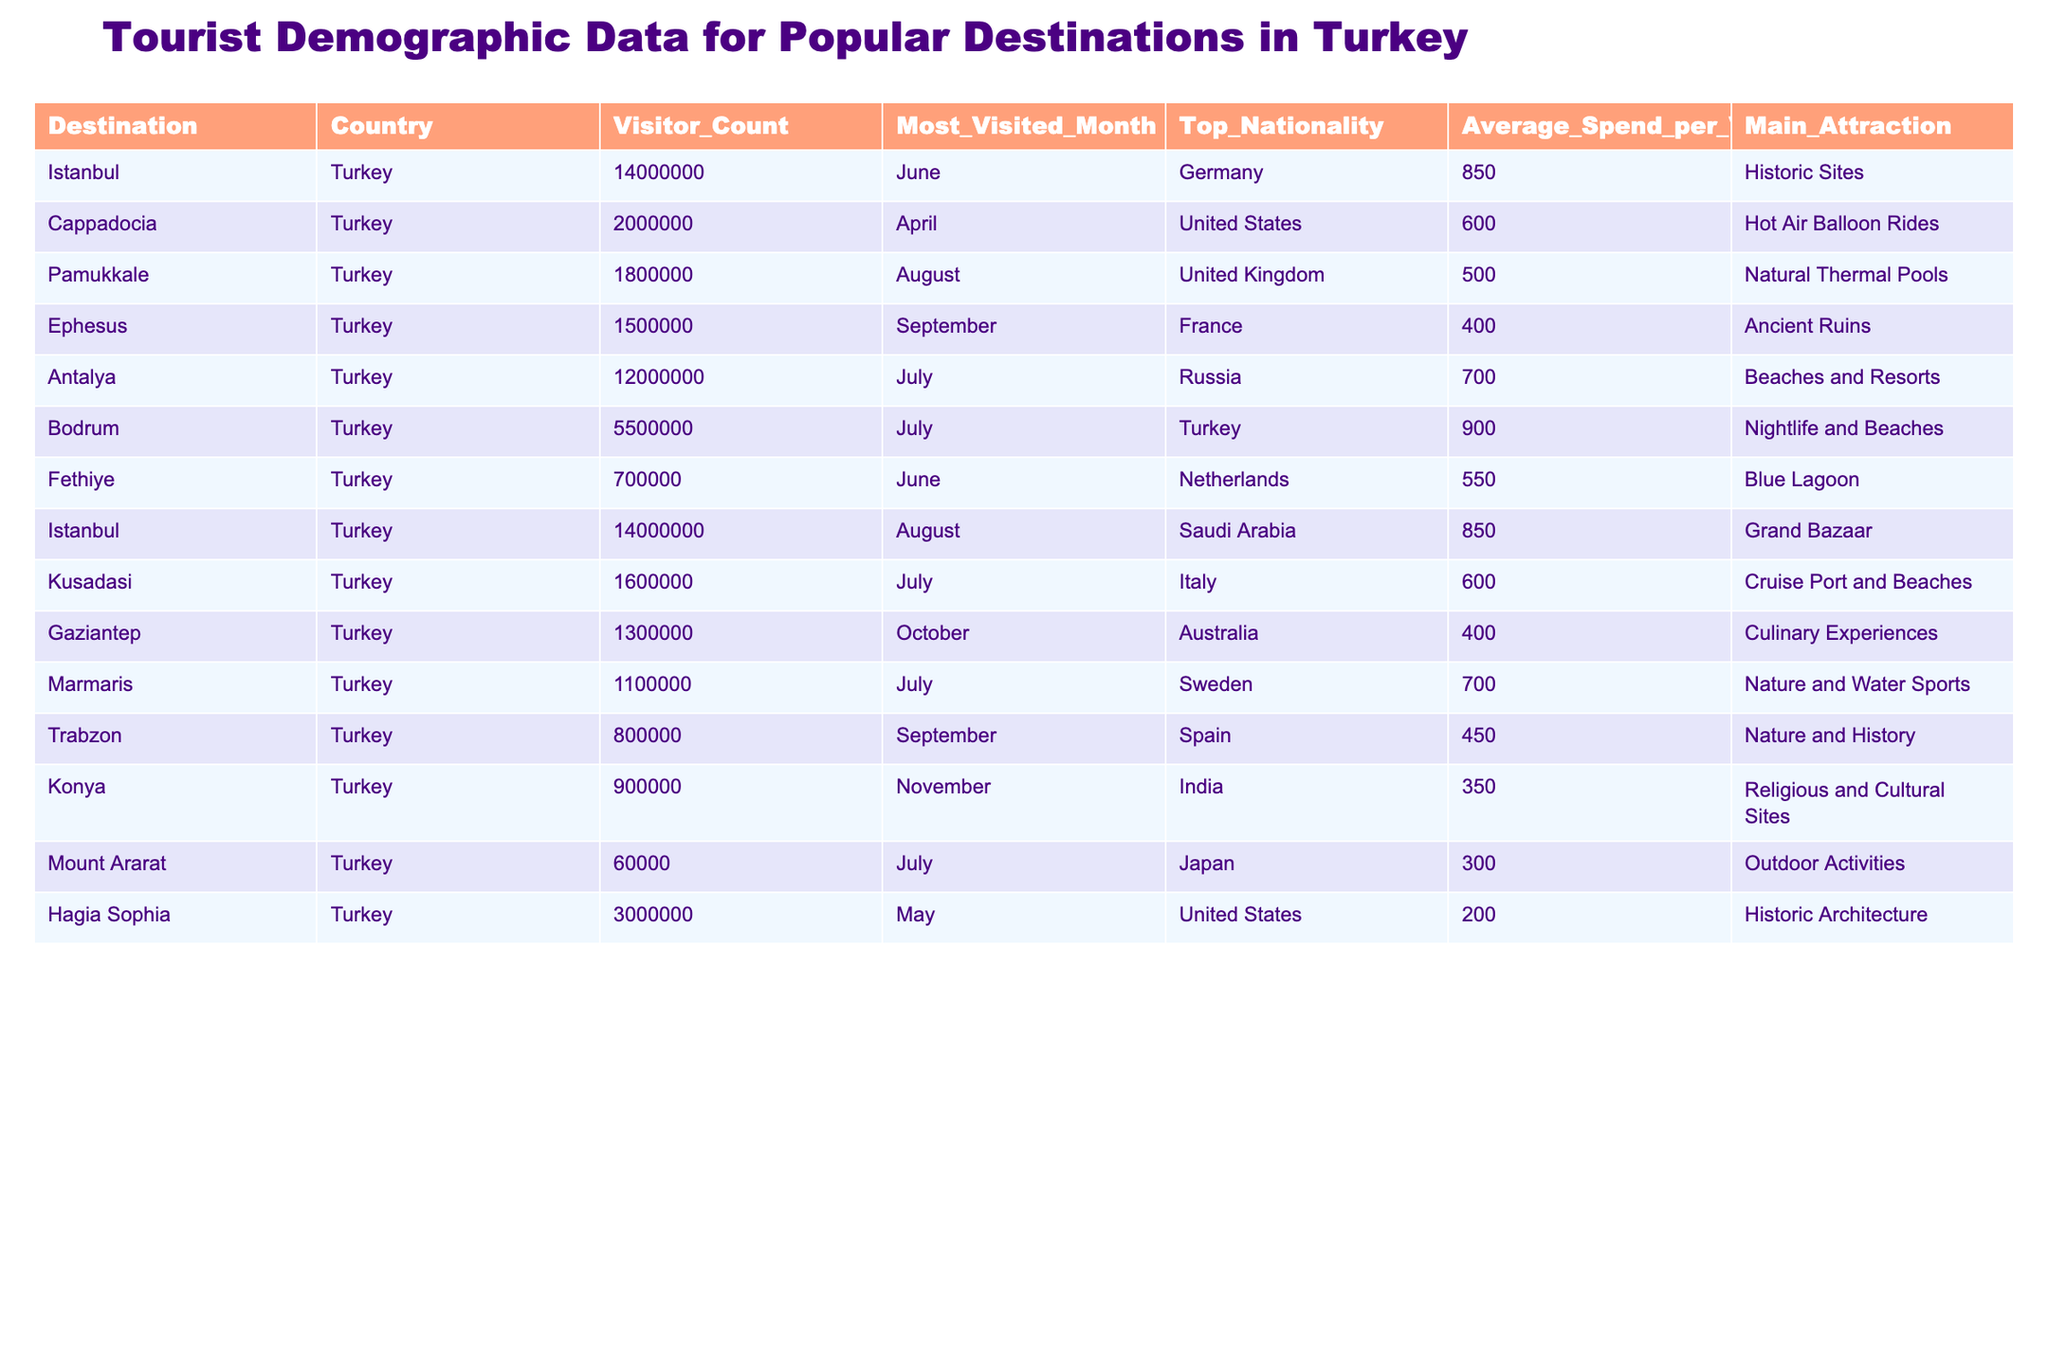What is the most visited month for Istanbul? According to the table, the most visited month for Istanbul is June as it appears under the "Most_Visited_Month" column for that destination.
Answer: June What is the average spend per visitor in Cappadocia? The table shows that the average spend per visitor in Cappadocia is 600.
Answer: 600 Which nationality has the highest visitor count in Antalya? The table indicates that the top nationality for Antalya's visitor count is Russia.
Answer: Russia What are the main attractions for visitors in Pamukkale? The table lists "Natural Thermal Pools" as the main attraction for Pamukkale under the "Main_Attraction" column.
Answer: Natural Thermal Pools Which destination has the highest visitor count? Istanbul has the highest visitor count at 14,000,000 as stated in the "Visitor_Count" column.
Answer: Istanbul How many visitors did Gaziantep receive? According to the table, Gaziantep received 1,300,000 visitors.
Answer: 1,300,000 What is the difference in average spend between Bodrum and Ephesus? The average spend per visitor in Bodrum is 900, while in Ephesus it is 400. The difference is calculated as 900 - 400 = 500.
Answer: 500 What percentage of visitors in Turkey come from the United States, based on the available data? To find the percentage, we sum the total visitors: 14,000,000 + 2,000,000 + 1,800,000 + 1,500,000 + 12,000,000 + 5,500,000 + 700,000 + 1,600,000 + 1,300,000 + 1,100,000 + 800,000 + 900,000 + 60,000 + 3,000,000 = 42,760,000. The visitors from the United States summed up to 2,000,000 + 3,000,000 = 5,000,000. Then: (5,000,000 / 42,760,000) * 100 = 11.7%.
Answer: 11.7% Is the main attraction in Mount Ararat related to outdoor activities? Yes, the table states that the main attraction in Mount Ararat is “Outdoor Activities,” confirming that it's related.
Answer: Yes Which location has the highest average spend per visitor among the listed destinations? The highest average spend is in Bodrum at 900 per visitor, as seen in the "Average_Spend_per_Visitor" column.
Answer: Bodrum What is the combined visitor count for destinations in July? The visitor count for July destinations includes Antalya (12,000,000), Bodrum (5,500,000), Kusadasi (1,600,000), and Marmaris (1,100,000). Adding these gives 12,000,000 + 5,500,000 + 1,600,000 + 1,100,000 = 20,200,000 visitors.
Answer: 20,200,000 Which country sends the most visitors to Ephesus? The table indicates that the top nationality visiting Ephesus is France.
Answer: France 